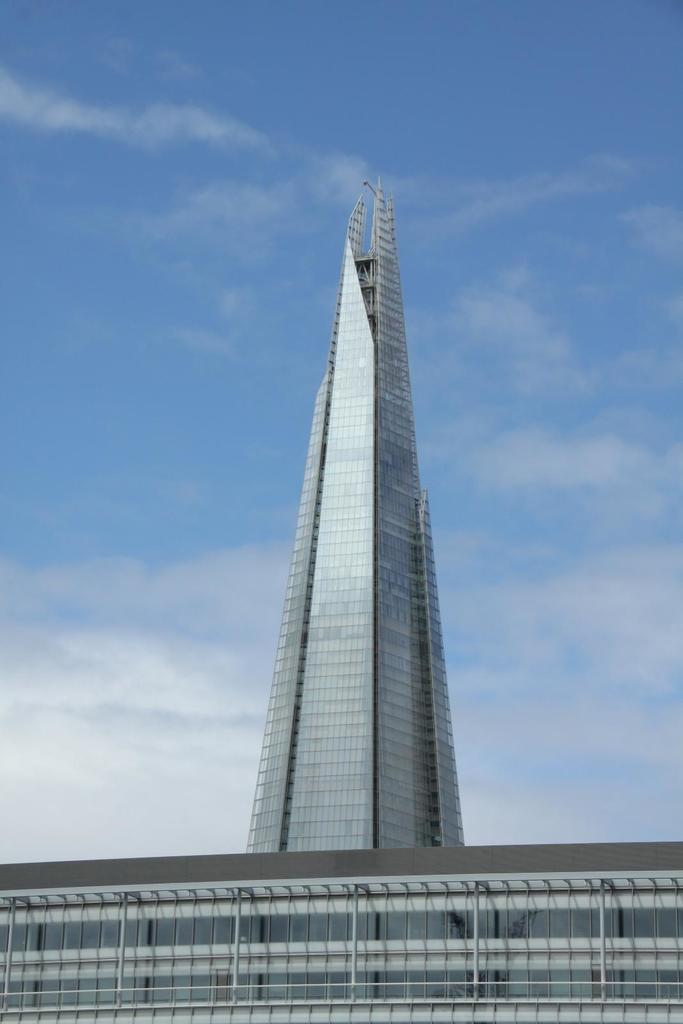What is the main subject in the picture? There is a building in the picture. What can be seen in the background of the picture? The sky is visible in the background of the picture. What type of stitch is used to hold the building together in the image? There is no mention of stitching or any materials used to construct the building in the image. 